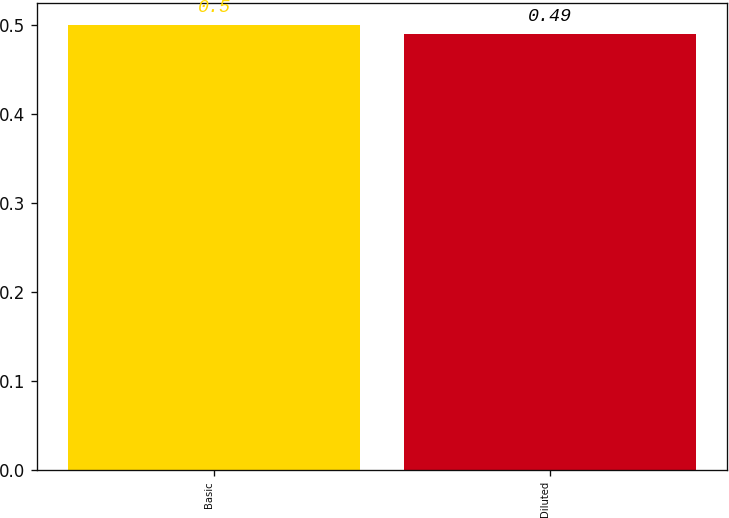<chart> <loc_0><loc_0><loc_500><loc_500><bar_chart><fcel>Basic<fcel>Diluted<nl><fcel>0.5<fcel>0.49<nl></chart> 